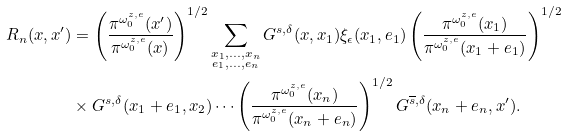Convert formula to latex. <formula><loc_0><loc_0><loc_500><loc_500>R _ { n } ( x , x ^ { \prime } ) & = \left ( \frac { \pi ^ { \omega _ { 0 } ^ { z , e } } ( x ^ { \prime } ) } { \pi ^ { \omega _ { 0 } ^ { z , e } } ( x ) } \right ) ^ { 1 / 2 } \sum _ { \substack { x _ { 1 } , \dots , x _ { n } \\ e _ { 1 } , \dots , e _ { n } } } G ^ { s , \delta } ( x , x _ { 1 } ) \xi _ { \epsilon } ( x _ { 1 } , e _ { 1 } ) \left ( \frac { \pi ^ { \omega _ { 0 } ^ { z , e } } ( x _ { 1 } ) } { \pi ^ { \omega _ { 0 } ^ { z , e } } ( x _ { 1 } + e _ { 1 } ) } \right ) ^ { 1 / 2 } \\ & \times G ^ { s , \delta } ( x _ { 1 } + e _ { 1 } , x _ { 2 } ) \cdots \left ( \frac { \pi ^ { \omega _ { 0 } ^ { z , e } } ( x _ { n } ) } { \pi ^ { \omega _ { 0 } ^ { z , e } } ( x _ { n } + e _ { n } ) } \right ) ^ { 1 / 2 } G ^ { \overline { s } , \delta } ( x _ { n } + e _ { n } , x ^ { \prime } ) .</formula> 